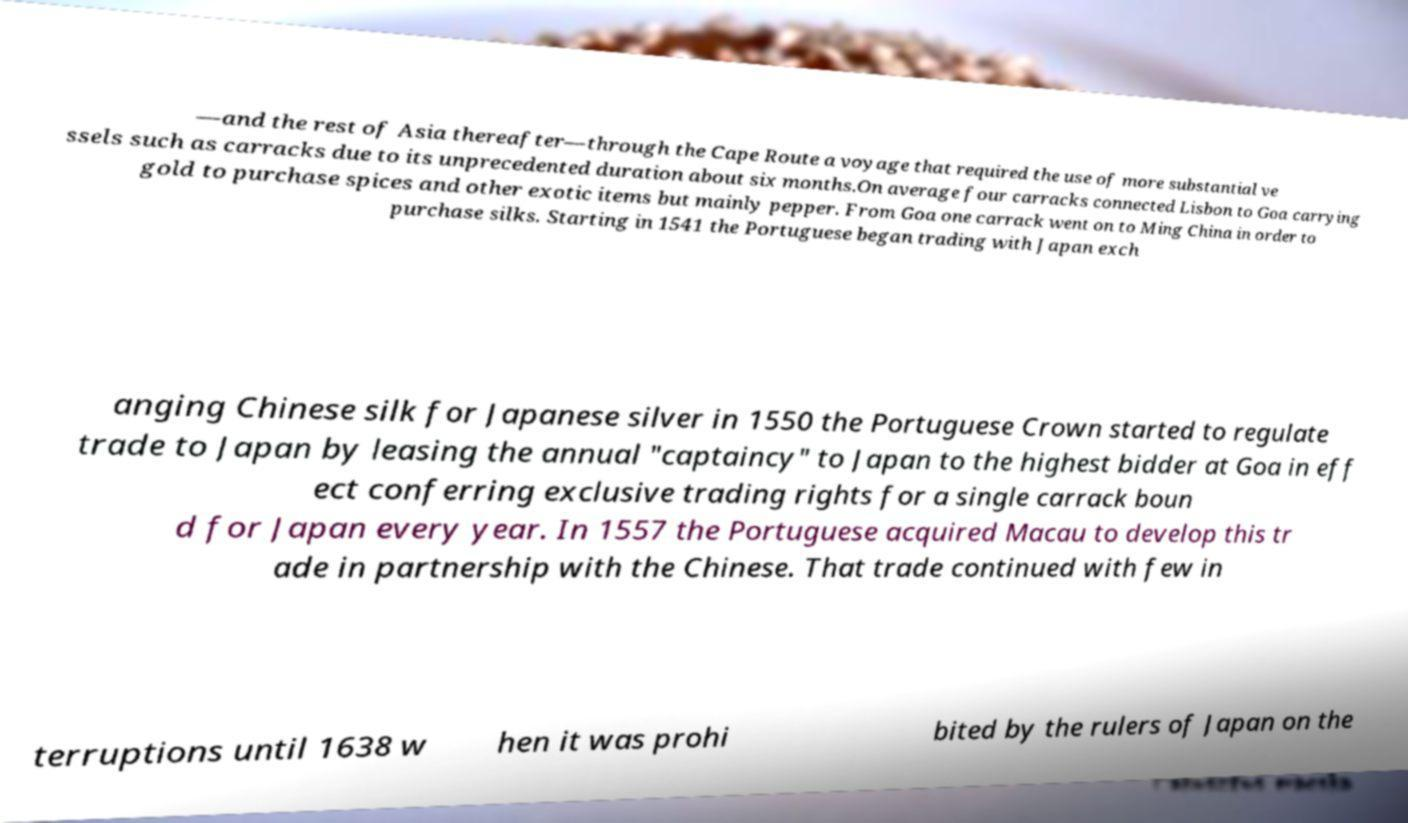For documentation purposes, I need the text within this image transcribed. Could you provide that? —and the rest of Asia thereafter—through the Cape Route a voyage that required the use of more substantial ve ssels such as carracks due to its unprecedented duration about six months.On average four carracks connected Lisbon to Goa carrying gold to purchase spices and other exotic items but mainly pepper. From Goa one carrack went on to Ming China in order to purchase silks. Starting in 1541 the Portuguese began trading with Japan exch anging Chinese silk for Japanese silver in 1550 the Portuguese Crown started to regulate trade to Japan by leasing the annual "captaincy" to Japan to the highest bidder at Goa in eff ect conferring exclusive trading rights for a single carrack boun d for Japan every year. In 1557 the Portuguese acquired Macau to develop this tr ade in partnership with the Chinese. That trade continued with few in terruptions until 1638 w hen it was prohi bited by the rulers of Japan on the 